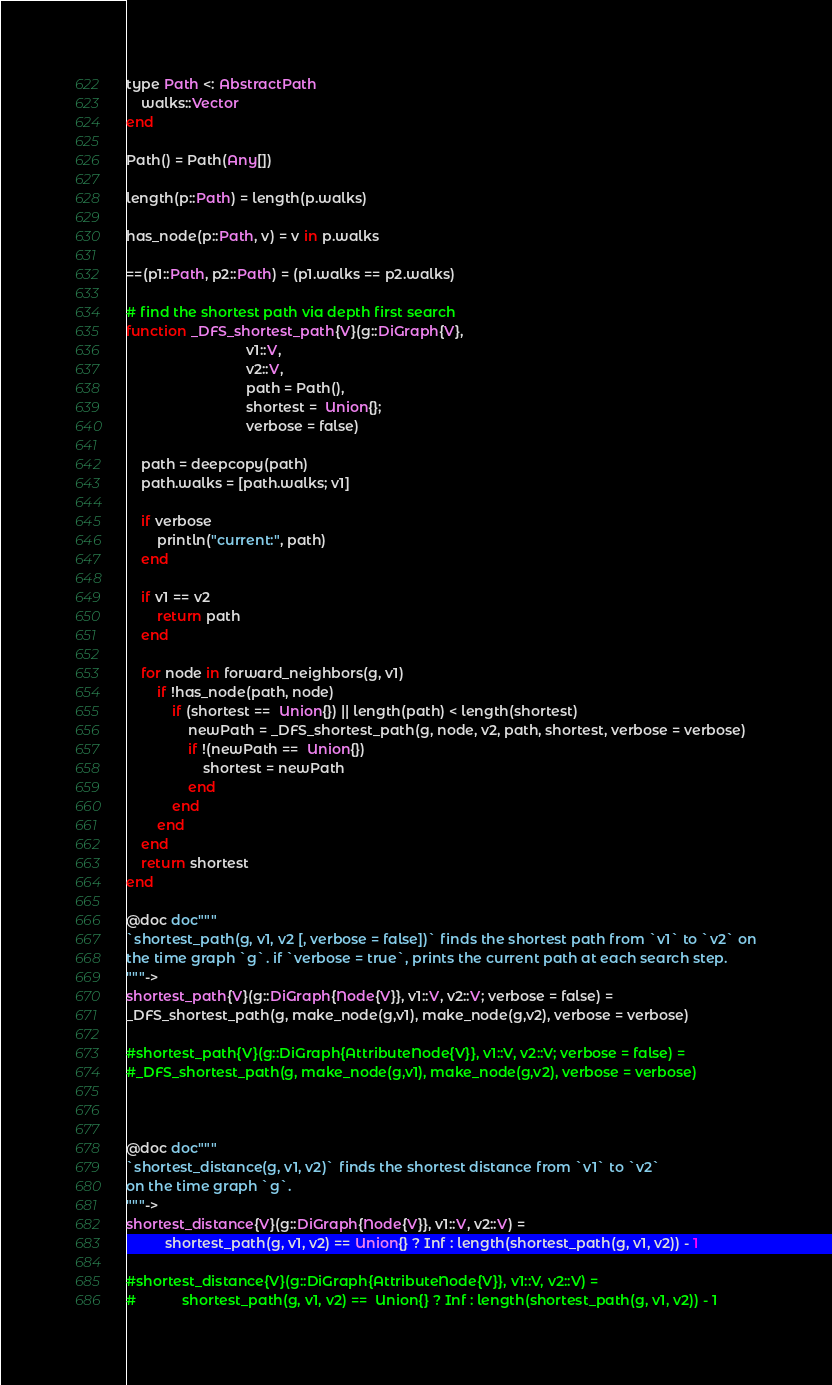<code> <loc_0><loc_0><loc_500><loc_500><_Julia_>type Path <: AbstractPath
    walks::Vector
end

Path() = Path(Any[])

length(p::Path) = length(p.walks)

has_node(p::Path, v) = v in p.walks

==(p1::Path, p2::Path) = (p1.walks == p2.walks)

# find the shortest path via depth first search
function _DFS_shortest_path{V}(g::DiGraph{V},
                               v1::V,
                               v2::V,
                               path = Path(),
                               shortest =  Union{};
                               verbose = false)

    path = deepcopy(path)
    path.walks = [path.walks; v1]

    if verbose
        println("current:", path)
    end

    if v1 == v2
        return path
    end

    for node in forward_neighbors(g, v1)
        if !has_node(path, node)
            if (shortest ==  Union{}) || length(path) < length(shortest)
                newPath = _DFS_shortest_path(g, node, v2, path, shortest, verbose = verbose)
                if !(newPath ==  Union{})
                    shortest = newPath
                end
            end
        end
    end
    return shortest
end

@doc doc"""
`shortest_path(g, v1, v2 [, verbose = false])` finds the shortest path from `v1` to `v2` on
the time graph `g`. if `verbose = true`, prints the current path at each search step.
"""->
shortest_path{V}(g::DiGraph{Node{V}}, v1::V, v2::V; verbose = false) =
_DFS_shortest_path(g, make_node(g,v1), make_node(g,v2), verbose = verbose)

#shortest_path{V}(g::DiGraph{AttributeNode{V}}, v1::V, v2::V; verbose = false) =
#_DFS_shortest_path(g, make_node(g,v1), make_node(g,v2), verbose = verbose)



@doc doc"""
`shortest_distance(g, v1, v2)` finds the shortest distance from `v1` to `v2`
on the time graph `g`.
"""->
shortest_distance{V}(g::DiGraph{Node{V}}, v1::V, v2::V) =
          shortest_path(g, v1, v2) == Union{} ? Inf : length(shortest_path(g, v1, v2)) - 1

#shortest_distance{V}(g::DiGraph{AttributeNode{V}}, v1::V, v2::V) =
#            shortest_path(g, v1, v2) ==  Union{} ? Inf : length(shortest_path(g, v1, v2)) - 1
</code> 